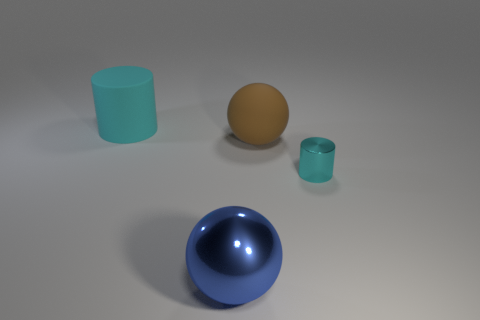Is there any other thing that has the same size as the cyan metal object?
Offer a very short reply. No. The tiny thing is what color?
Your answer should be very brief. Cyan. Does the blue shiny sphere have the same size as the metal cylinder?
Give a very brief answer. No. How many things are big blue balls or green shiny objects?
Give a very brief answer. 1. Are there an equal number of matte balls that are in front of the small cylinder and big metal things?
Offer a terse response. No. Are there any large cyan things to the left of the cyan object right of the large ball that is behind the cyan shiny cylinder?
Your answer should be very brief. Yes. The cylinder that is the same material as the blue object is what color?
Offer a terse response. Cyan. There is a cylinder in front of the cyan rubber cylinder; is its color the same as the large matte cylinder?
Offer a very short reply. Yes. What number of cylinders are either big matte objects or blue shiny objects?
Your answer should be compact. 1. What is the size of the cyan object that is on the right side of the matte thing in front of the cyan cylinder that is behind the big brown thing?
Your answer should be very brief. Small. 